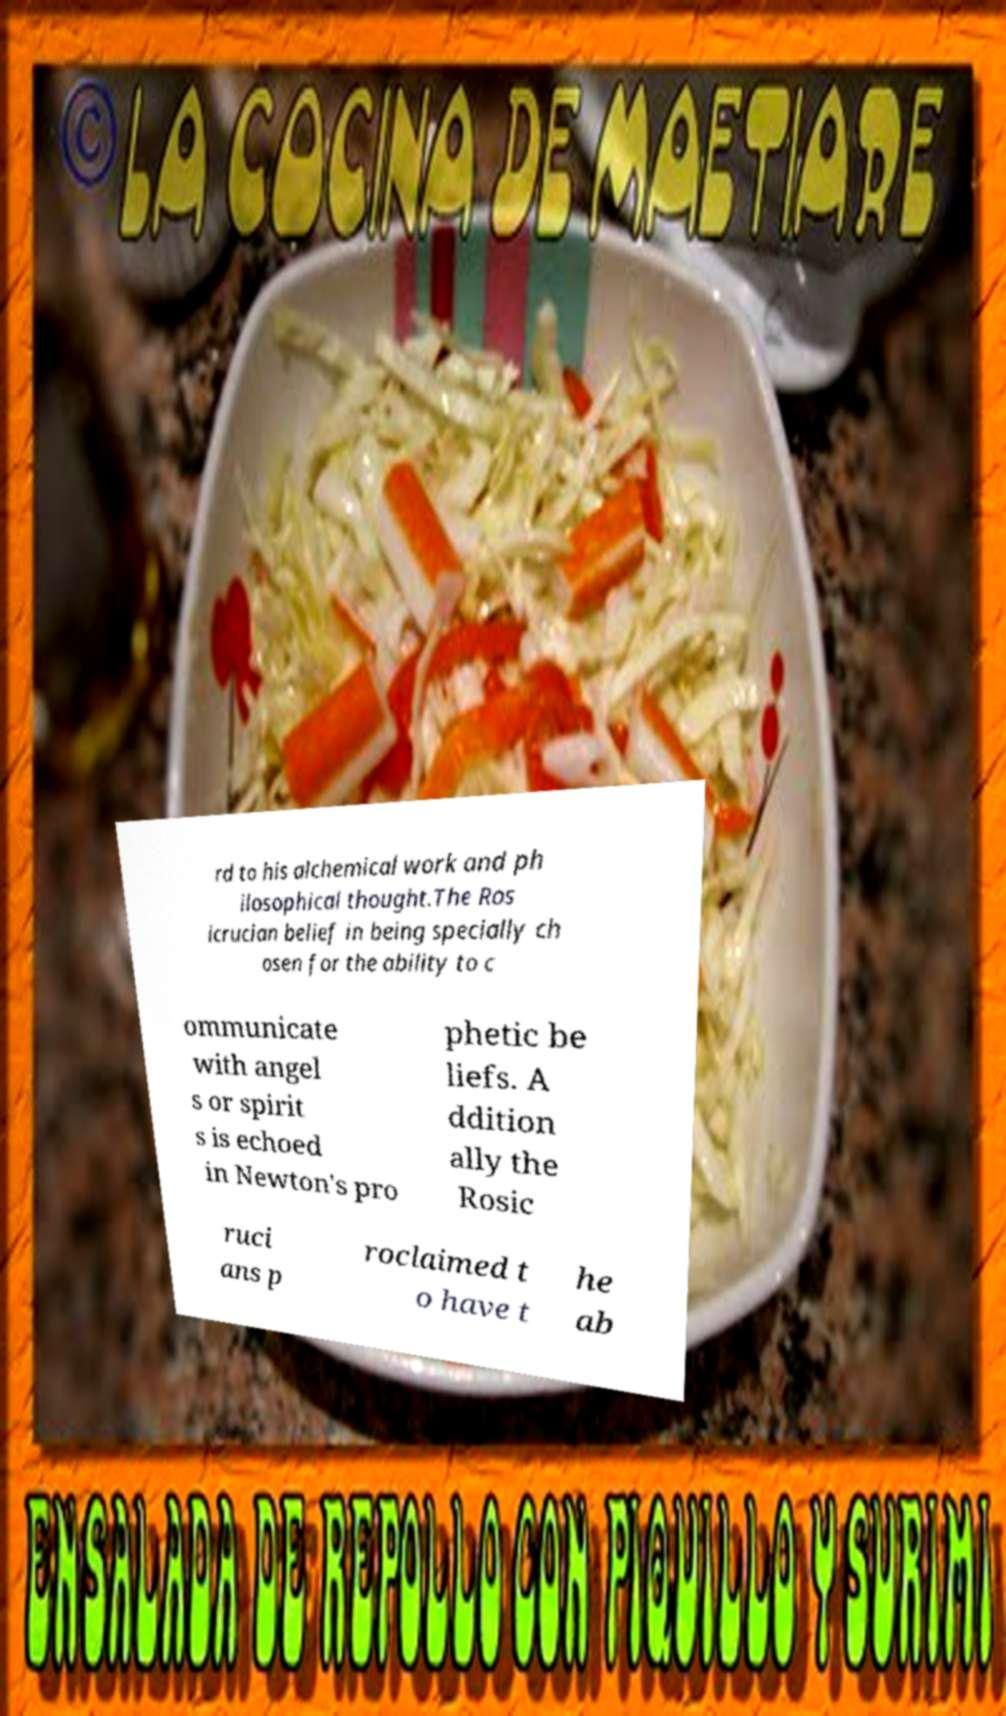Could you extract and type out the text from this image? rd to his alchemical work and ph ilosophical thought.The Ros icrucian belief in being specially ch osen for the ability to c ommunicate with angel s or spirit s is echoed in Newton's pro phetic be liefs. A ddition ally the Rosic ruci ans p roclaimed t o have t he ab 